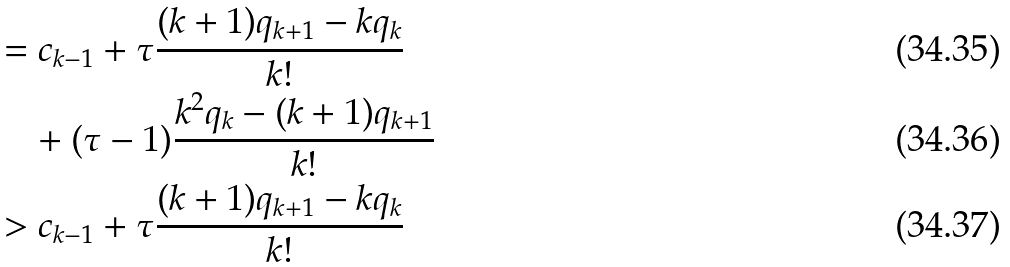Convert formula to latex. <formula><loc_0><loc_0><loc_500><loc_500>& = c _ { k - 1 } + \tau \frac { ( k + 1 ) q _ { k + 1 } - k q _ { k } } { k ! } \\ & \quad + ( \tau - 1 ) \frac { k ^ { 2 } q _ { k } - ( k + 1 ) q _ { k + 1 } } { k ! } \\ & > c _ { k - 1 } + \tau \frac { ( k + 1 ) q _ { k + 1 } - k q _ { k } } { k ! }</formula> 